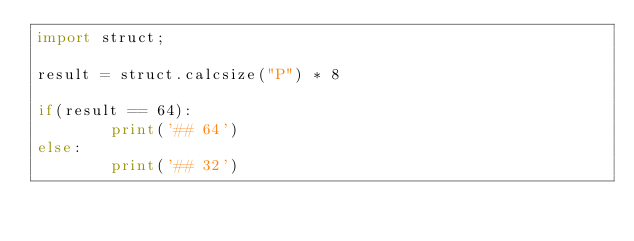Convert code to text. <code><loc_0><loc_0><loc_500><loc_500><_Python_>import struct;

result = struct.calcsize("P") * 8

if(result == 64):
        print('## 64')
else:
        print('## 32')

</code> 